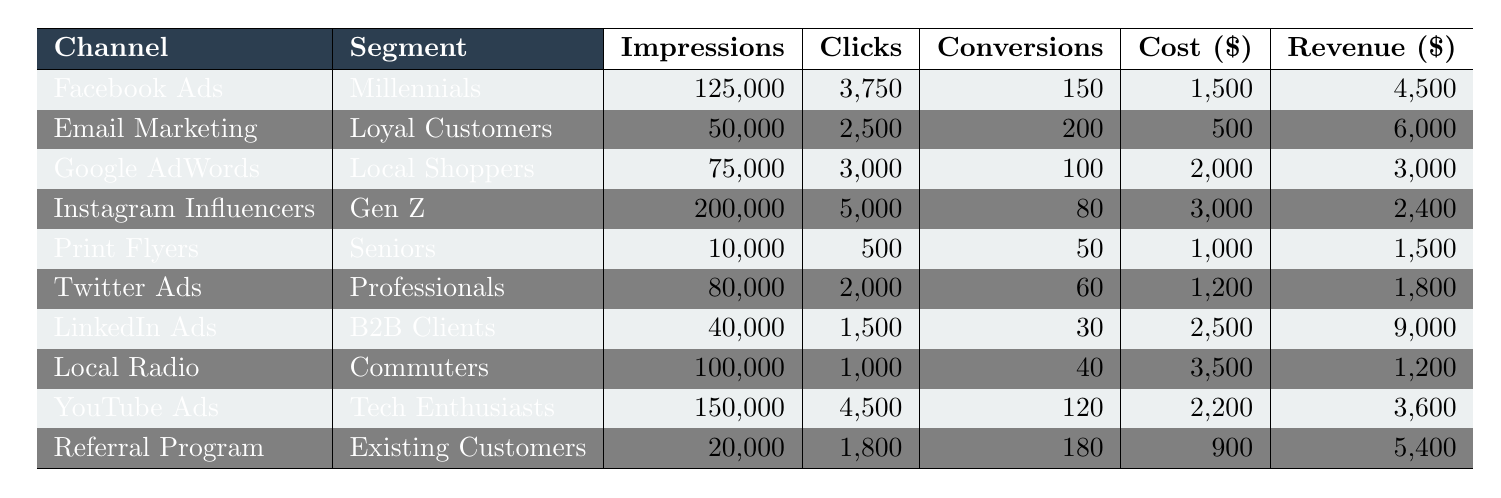What is the revenue generated from Email Marketing? The table shows that Email Marketing generated $6,000 in revenue.
Answer: $6,000 Which channel had the highest number of conversions? The highest number of conversions is 200, achieved by Email Marketing.
Answer: Email Marketing What is the total cost of the marketing campaigns? The total cost is calculated as $1,500 + $500 + $2,000 + $3,000 + $1,000 + $1,200 + $2,500 + $3,500 + $2,200 + $900 = $18,300.
Answer: $18,300 Did the Referral Program have more conversions than Print Flyers? Yes, the Referral Program had 180 conversions while Print Flyers had 50 conversions.
Answer: Yes What is the average cost per conversion across all channels? To calculate the average cost per conversion, first find the total conversions: 150 + 200 + 100 + 80 + 50 + 60 + 30 + 40 + 120 + 180 = 1,110. The total cost is $18,300, so the average cost per conversion is $18,300 / 1,110 ≈ $16.47.
Answer: $16.47 How much revenue was generated by the channel with the least impressions? Print Flyers had the least impressions at 10,000 and generated $1,500 in revenue.
Answer: $1,500 Which customer segment had the highest conversions and what was the figure? The customer segment with the highest conversions is "Loyal Customers" with 200 conversions from Email Marketing.
Answer: Loyal Customers, 200 conversions What channel had the least revenue, and how much was it? Instagram Influencers had the least revenue at $2,400.
Answer: $2,400 If you consider only digital channels, which channel had the best return on investment (ROI) and what was it? The ROI for each channel is calculated as (revenue - cost) / cost. The best ROI among digital channels is calculated for LinkedIn Ads: (9,000 - 2,500) / 2,500 = 2.8 or 280%.
Answer: LinkedIn Ads, 280% Is there any channel that generated more revenue than all others combined? No, the total revenue from all channels is $6,000 + $4,500 + $3,000 + $2,400 + $1,500 + $1,800 + $9,000 + $1,200 + $3,600 + $5,400 = $38,500, which no single channel exceeds.
Answer: No 